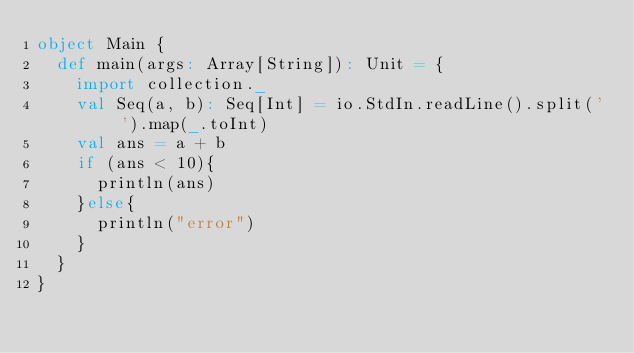Convert code to text. <code><loc_0><loc_0><loc_500><loc_500><_Scala_>object Main {
  def main(args: Array[String]): Unit = {
    import collection._
    val Seq(a, b): Seq[Int] = io.StdIn.readLine().split(' ').map(_.toInt)
    val ans = a + b
    if (ans < 10){
      println(ans)
    }else{
      println("error")
    }
  }
}</code> 